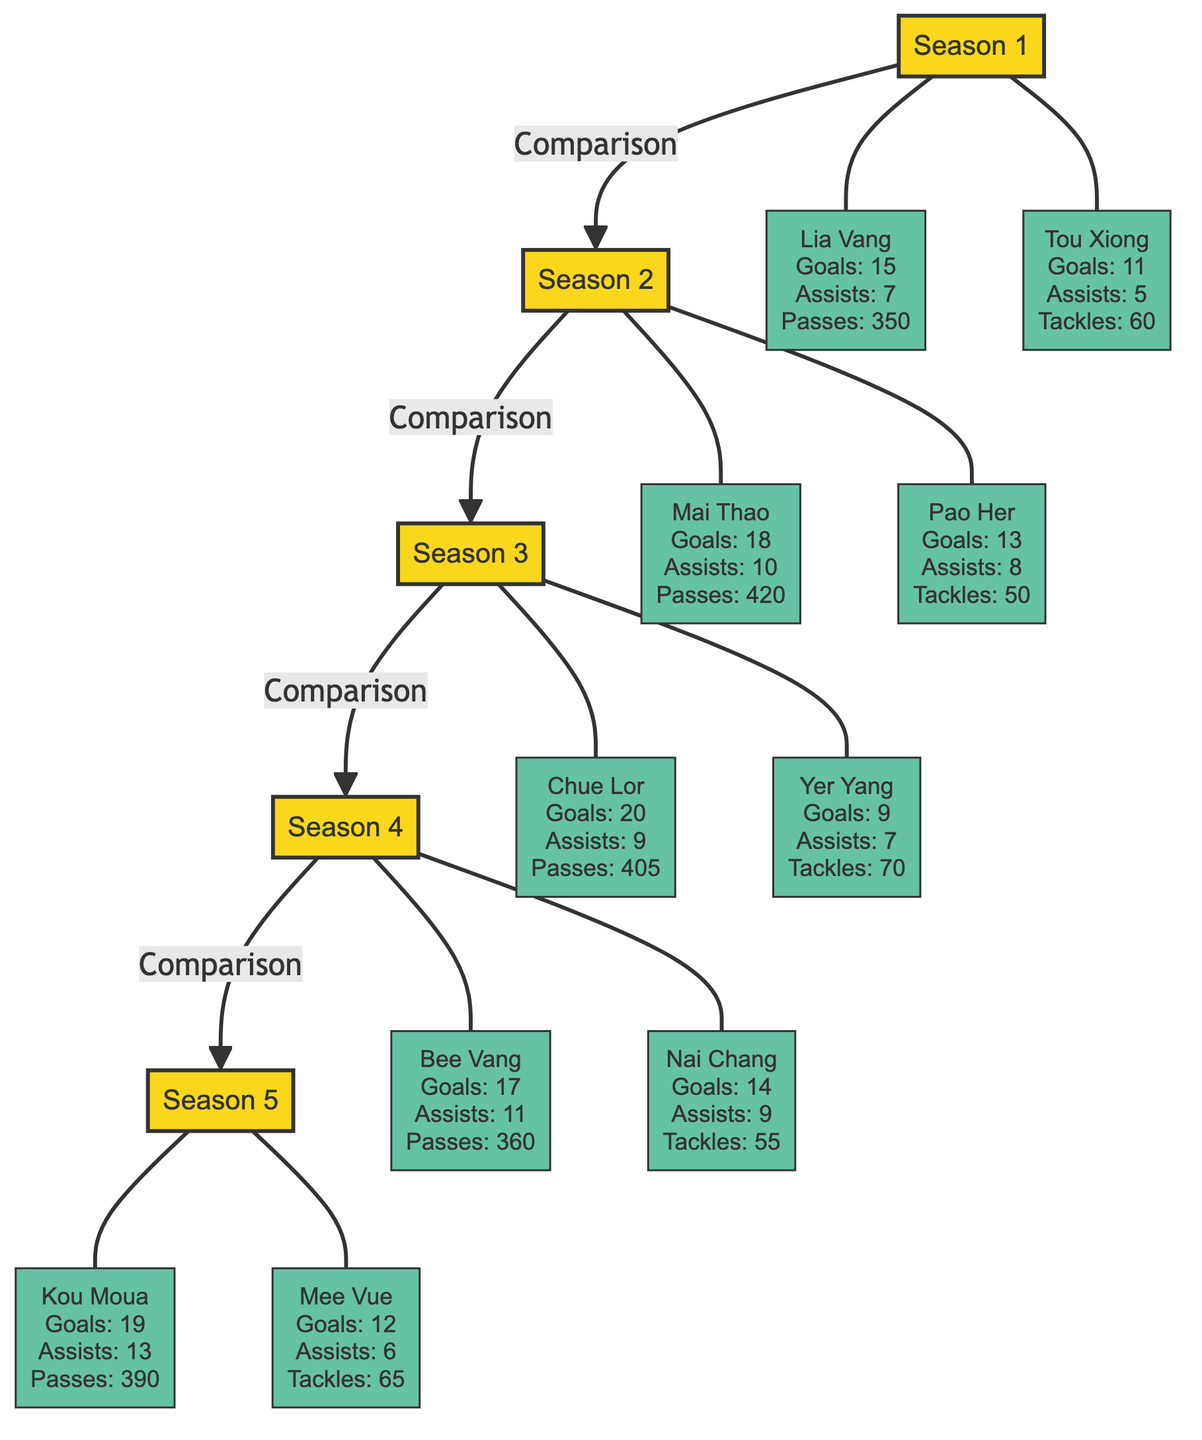What were Lia Vang's goals in Season 1? The diagram indicates that Lia Vang scored 15 goals in Season 1, which is explicitly stated in the corresponding information node.
Answer: 15 Which player scored the most goals in Season 3? By examining the information from Season 3, Chue Lor is noted as having the highest goals at 20, while comparing the goals of both players listed for that season reveals that no one scored more.
Answer: Chue Lor How many total assists did Kou Moua and Mee Vue have in Season 5? In Season 5, Kou Moua had 13 assists and Mee Vue had 6. Adding these figures together results in 13 + 6 = 19 assists in total.
Answer: 19 Which season had the player with the highest assists overall? By reviewing each season's players, Season 4's Bee Vang achieves the most with 11 assists, which is more than any other player across all seasons.
Answer: Season 4 How many players were compared in total across all seasons? Counting the players shown in the diagram, there are 10 players, as two players from each of the five seasons are compared, resulting in 5 x 2 = 10 total players.
Answer: 10 In which season did the player with the most tackles play? Looking at all players’ stats, Yer Yang from Season 3 had the highest number of tackles at 70, making Season 3 the season with the highest tackles.
Answer: Season 3 What is the relationship between Season 2 and Season 3? The diagram illustrates a direct comparison from Season 2 to Season 3, shown by the directed edge that connects S2 and S3, indicating a sequential relationship in their performances.
Answer: Comparison Which Hmong player had the least number of assists across all seasons? By reviewing all assists recorded for each player, the least assists are attributed to Tou Xiong, who had 5 assists in Season 1, making him the player with the least across all seasons.
Answer: Tou Xiong 